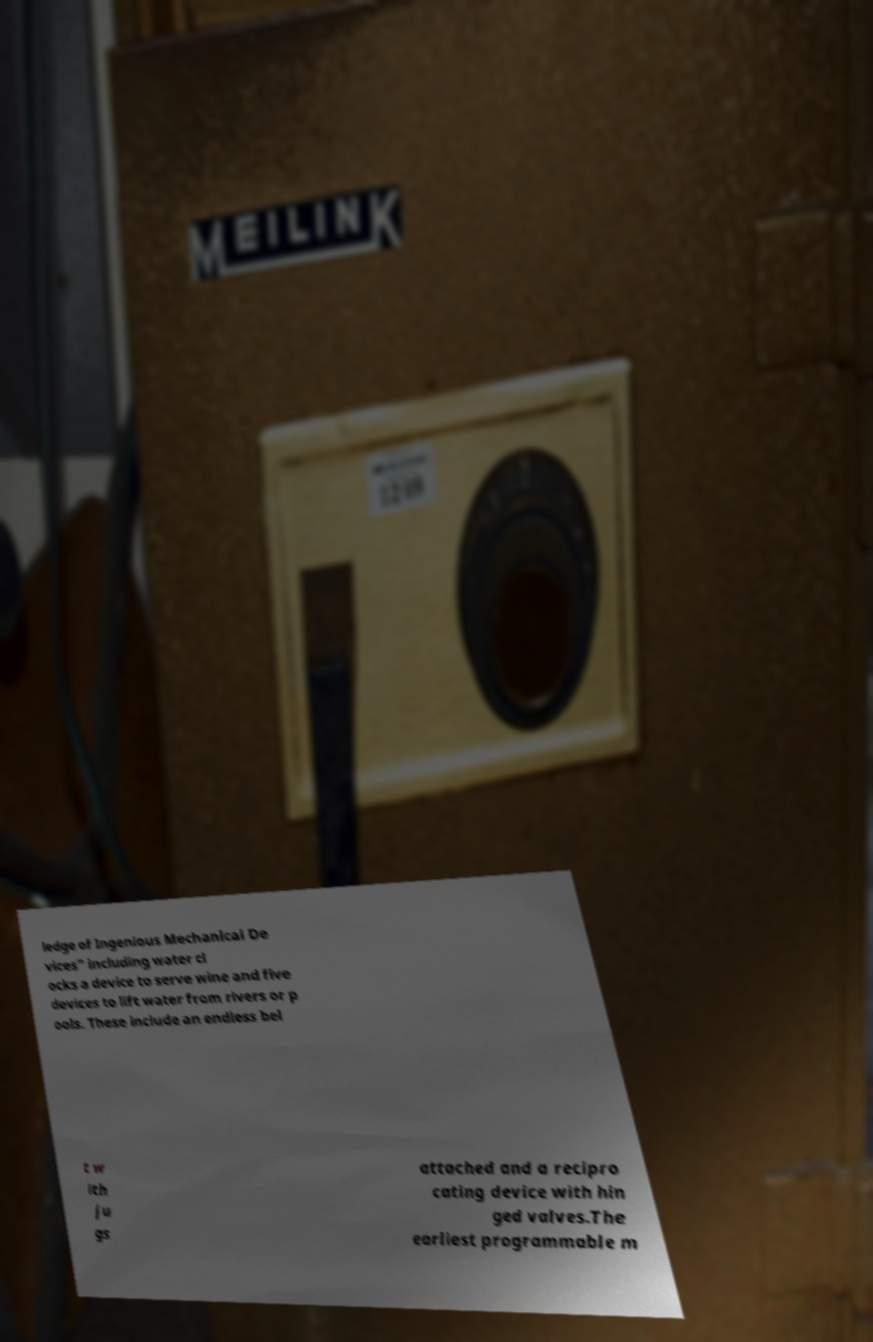Please read and relay the text visible in this image. What does it say? ledge of Ingenious Mechanical De vices" including water cl ocks a device to serve wine and five devices to lift water from rivers or p ools. These include an endless bel t w ith ju gs attached and a recipro cating device with hin ged valves.The earliest programmable m 